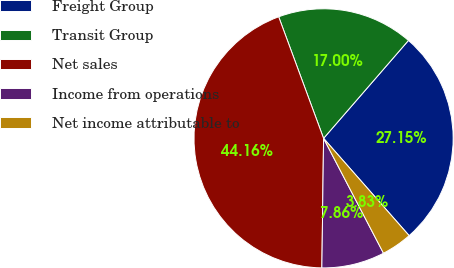<chart> <loc_0><loc_0><loc_500><loc_500><pie_chart><fcel>Freight Group<fcel>Transit Group<fcel>Net sales<fcel>Income from operations<fcel>Net income attributable to<nl><fcel>27.15%<fcel>17.0%<fcel>44.16%<fcel>7.86%<fcel>3.83%<nl></chart> 